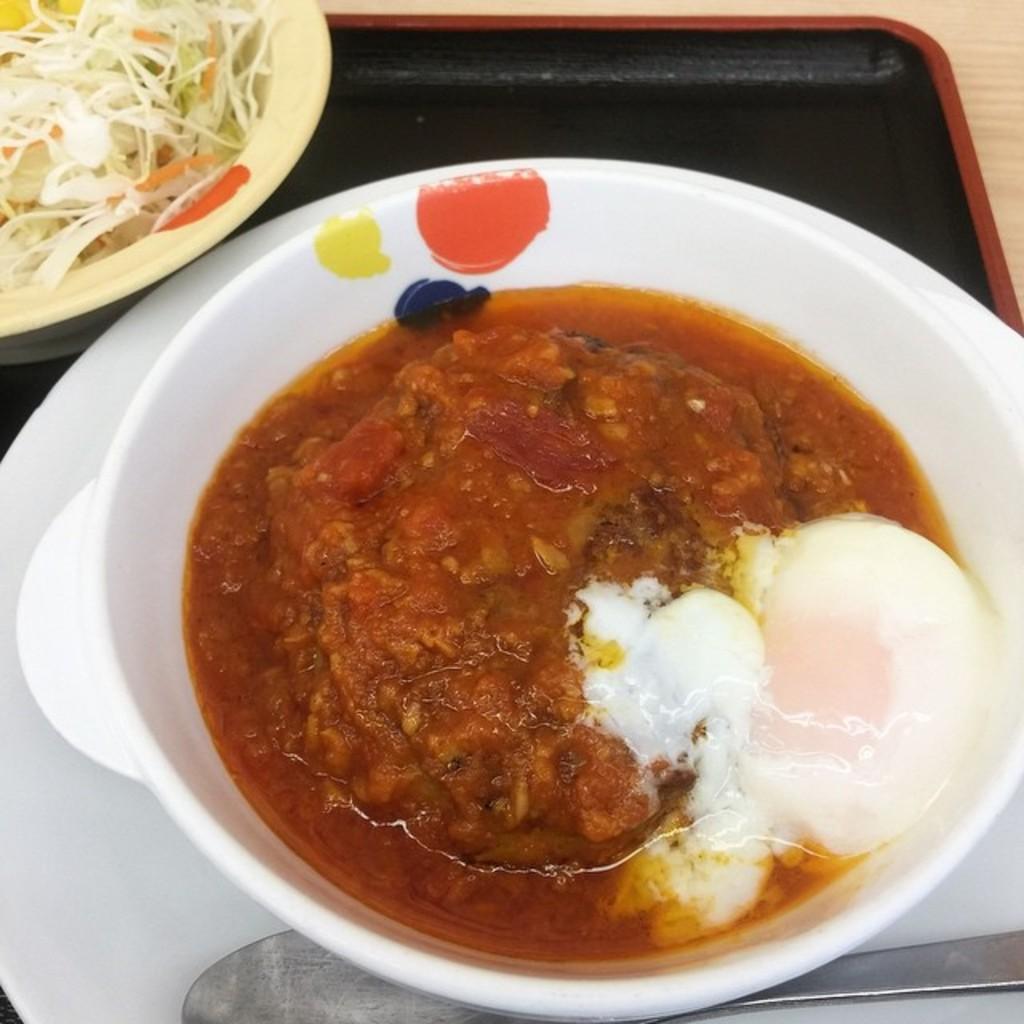Please provide a concise description of this image. In this image, we can see a table. On that table, we can see a tray which is in black color. In the middle of the tray, we can see a plate with a spoon and a bowl with some food item. On the left side of the tray, we can also see a bowl with some food. 